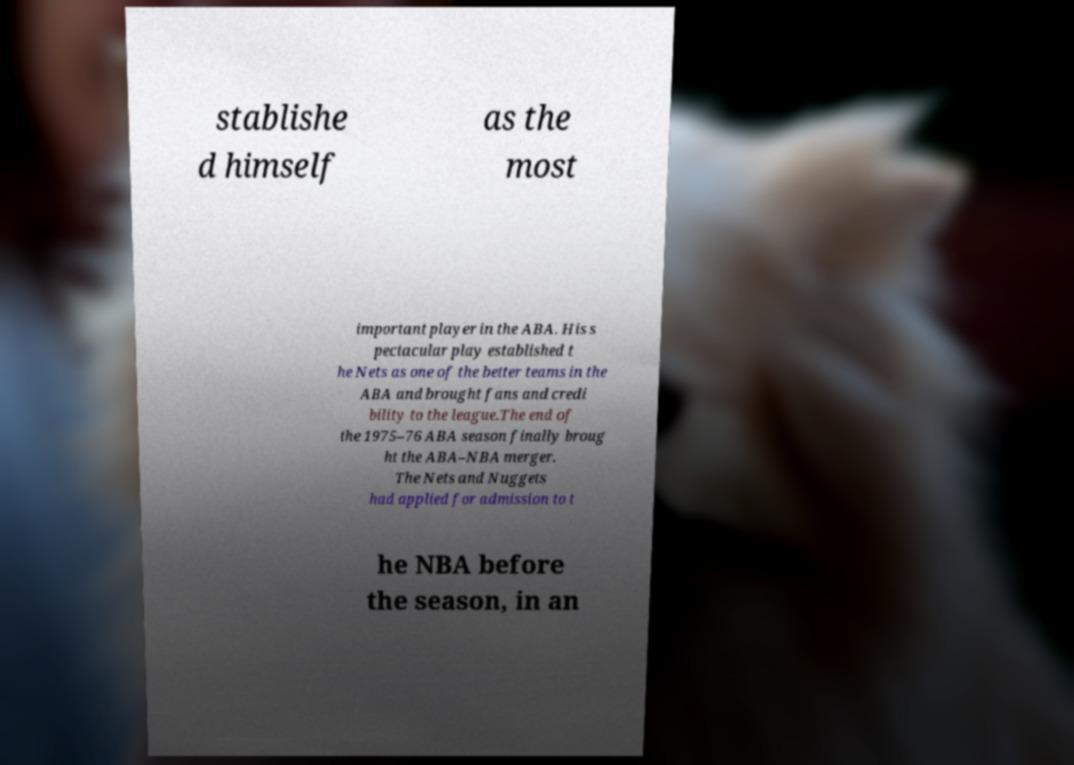There's text embedded in this image that I need extracted. Can you transcribe it verbatim? stablishe d himself as the most important player in the ABA. His s pectacular play established t he Nets as one of the better teams in the ABA and brought fans and credi bility to the league.The end of the 1975–76 ABA season finally broug ht the ABA–NBA merger. The Nets and Nuggets had applied for admission to t he NBA before the season, in an 